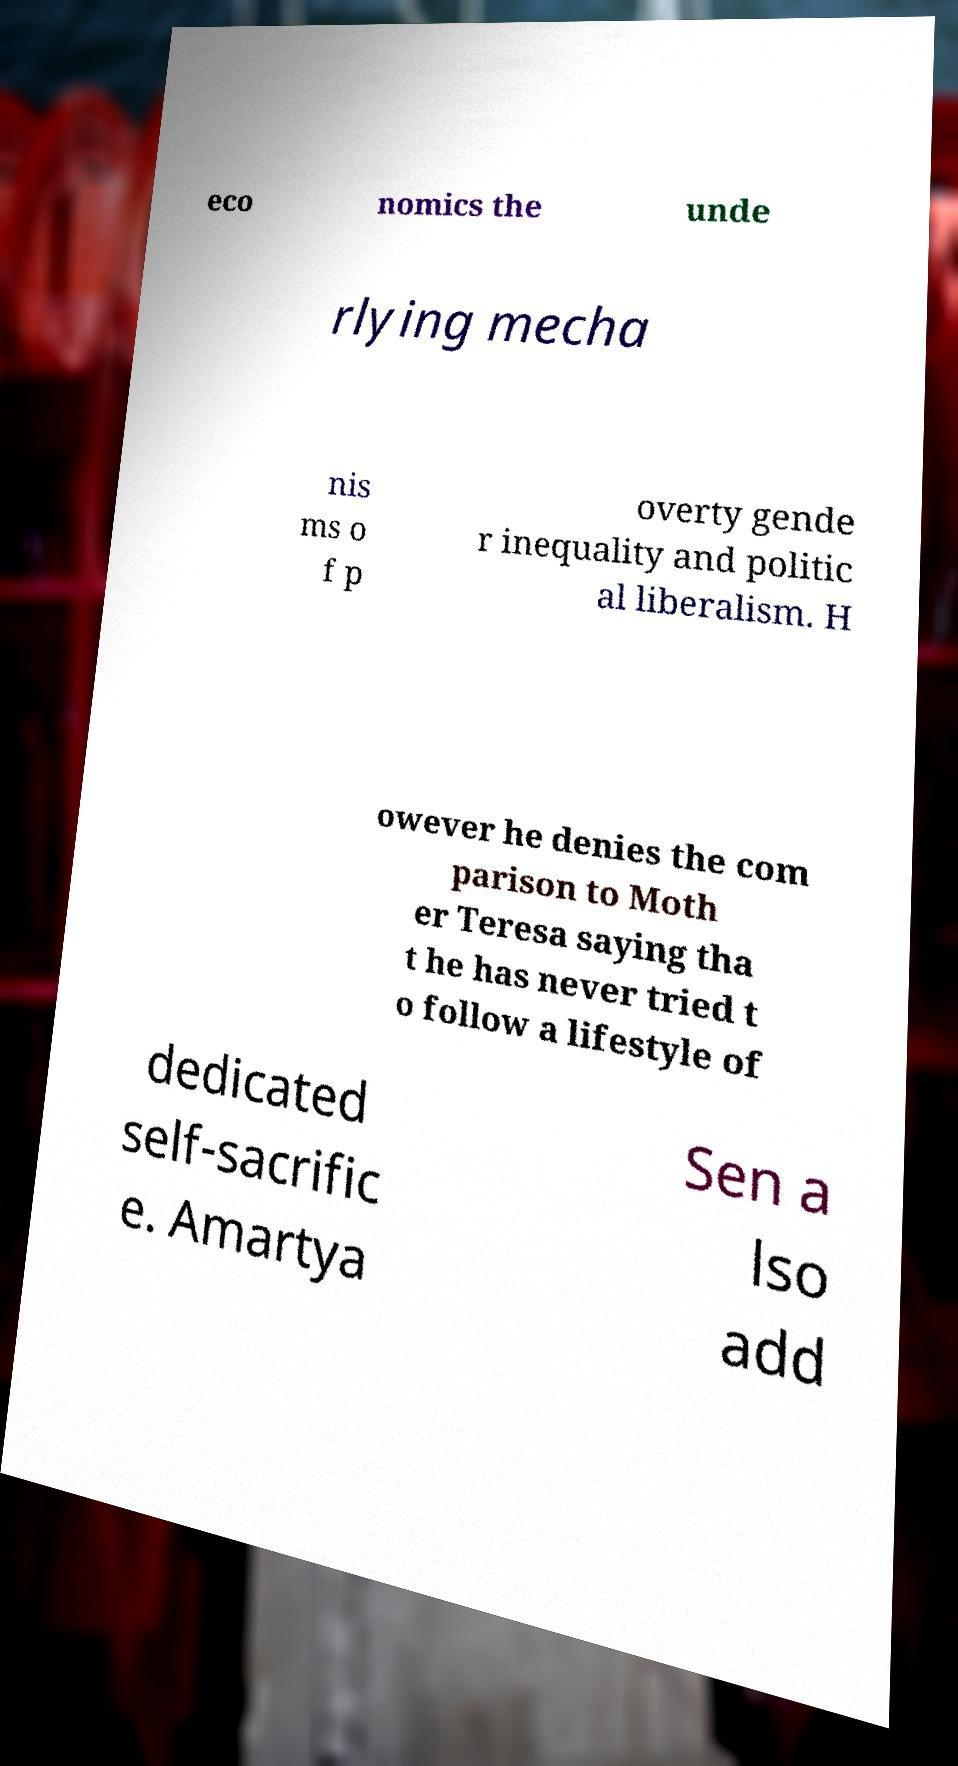There's text embedded in this image that I need extracted. Can you transcribe it verbatim? eco nomics the unde rlying mecha nis ms o f p overty gende r inequality and politic al liberalism. H owever he denies the com parison to Moth er Teresa saying tha t he has never tried t o follow a lifestyle of dedicated self-sacrific e. Amartya Sen a lso add 